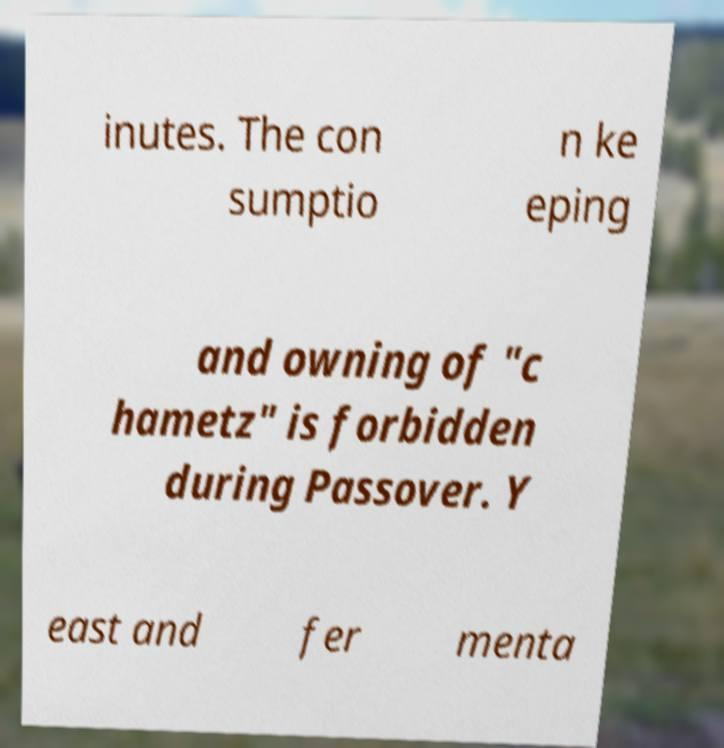Please identify and transcribe the text found in this image. inutes. The con sumptio n ke eping and owning of "c hametz" is forbidden during Passover. Y east and fer menta 